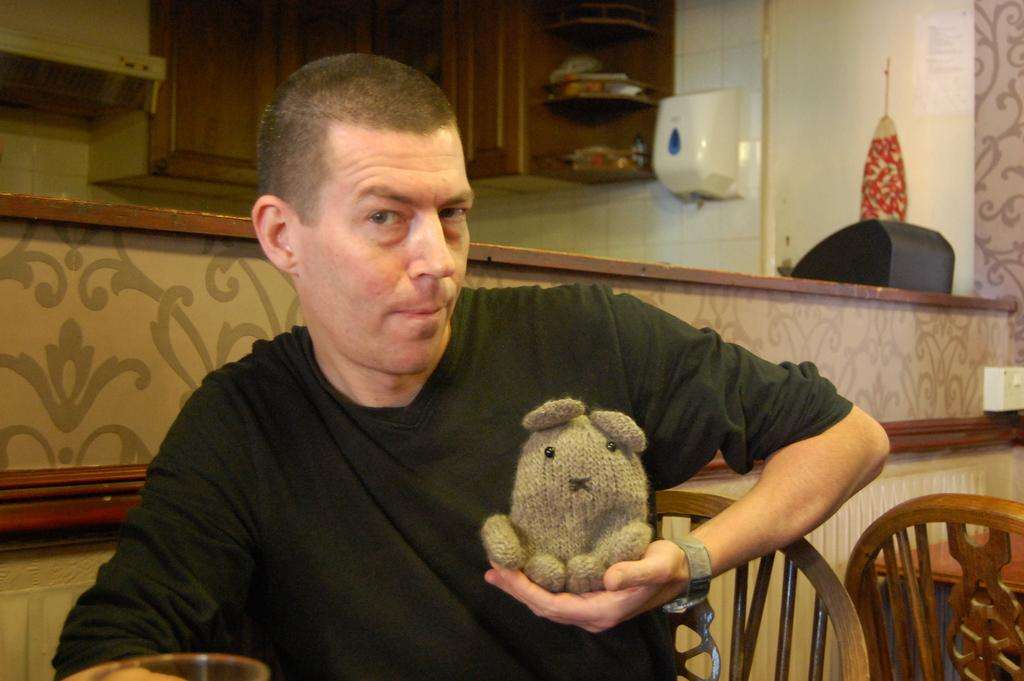What is the main subject of the image? There is a man in the image. What is the man doing in the image? The man is sitting on a chair. What is the man holding in the image? The man is holding a soft toy. What can be seen in the background of the image? There is a wall, another chair, a table, and cabinets in the background of the image. What type of guitar can be seen on the table in the image? There is no guitar present in the image; it only features a man sitting on a chair, holding a soft toy, and the background elements mentioned earlier. 